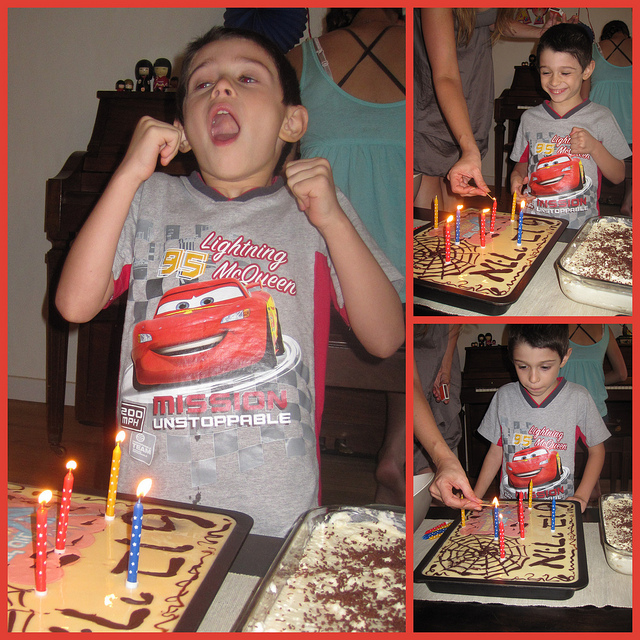Read and extract the text from this image. 95 Lightning McQueen MISSION UNSTOPPABLE 200 Lightning 95 Light 